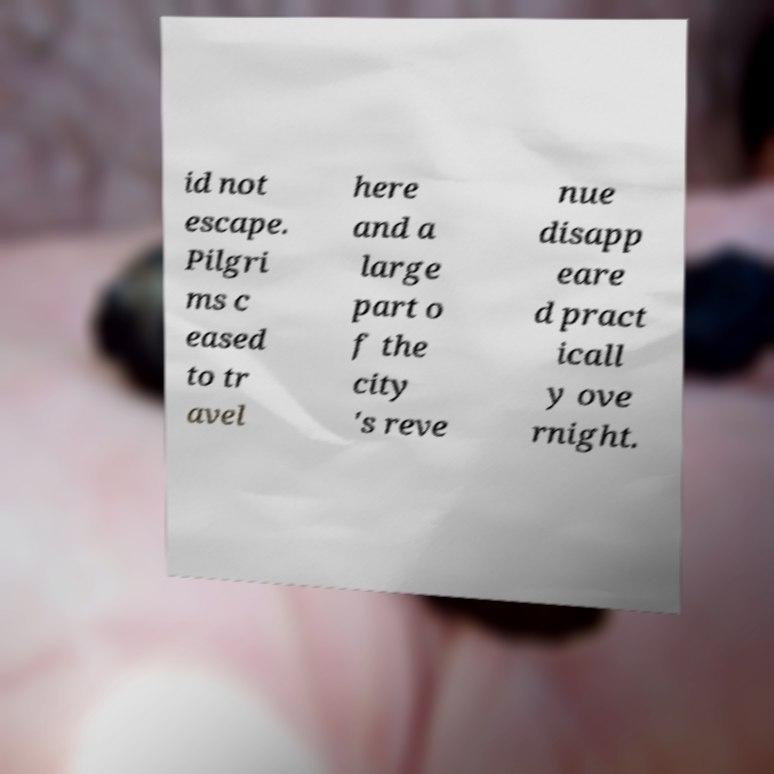Could you extract and type out the text from this image? id not escape. Pilgri ms c eased to tr avel here and a large part o f the city 's reve nue disapp eare d pract icall y ove rnight. 